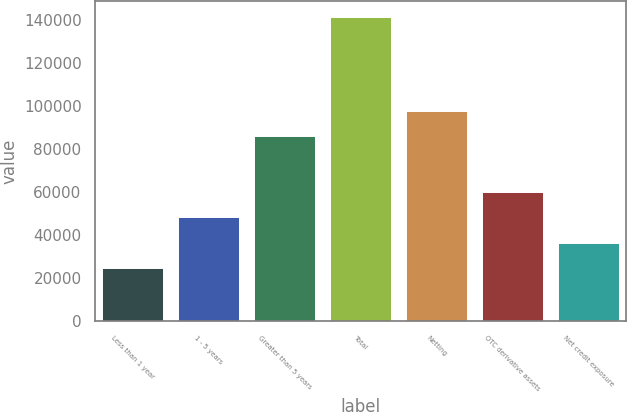<chart> <loc_0><loc_0><loc_500><loc_500><bar_chart><fcel>Less than 1 year<fcel>1 - 5 years<fcel>Greater than 5 years<fcel>Total<fcel>Netting<fcel>OTC derivative assets<fcel>Net credit exposure<nl><fcel>24840<fcel>48190.4<fcel>85951<fcel>141592<fcel>97626.2<fcel>59865.6<fcel>36515.2<nl></chart> 